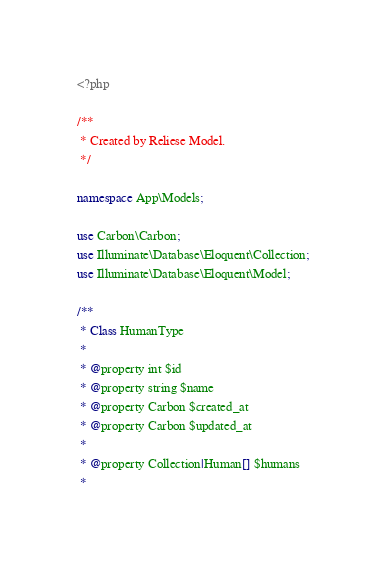Convert code to text. <code><loc_0><loc_0><loc_500><loc_500><_PHP_><?php

/**
 * Created by Reliese Model.
 */

namespace App\Models;

use Carbon\Carbon;
use Illuminate\Database\Eloquent\Collection;
use Illuminate\Database\Eloquent\Model;

/**
 * Class HumanType
 * 
 * @property int $id
 * @property string $name
 * @property Carbon $created_at
 * @property Carbon $updated_at
 * 
 * @property Collection|Human[] $humans
 *</code> 